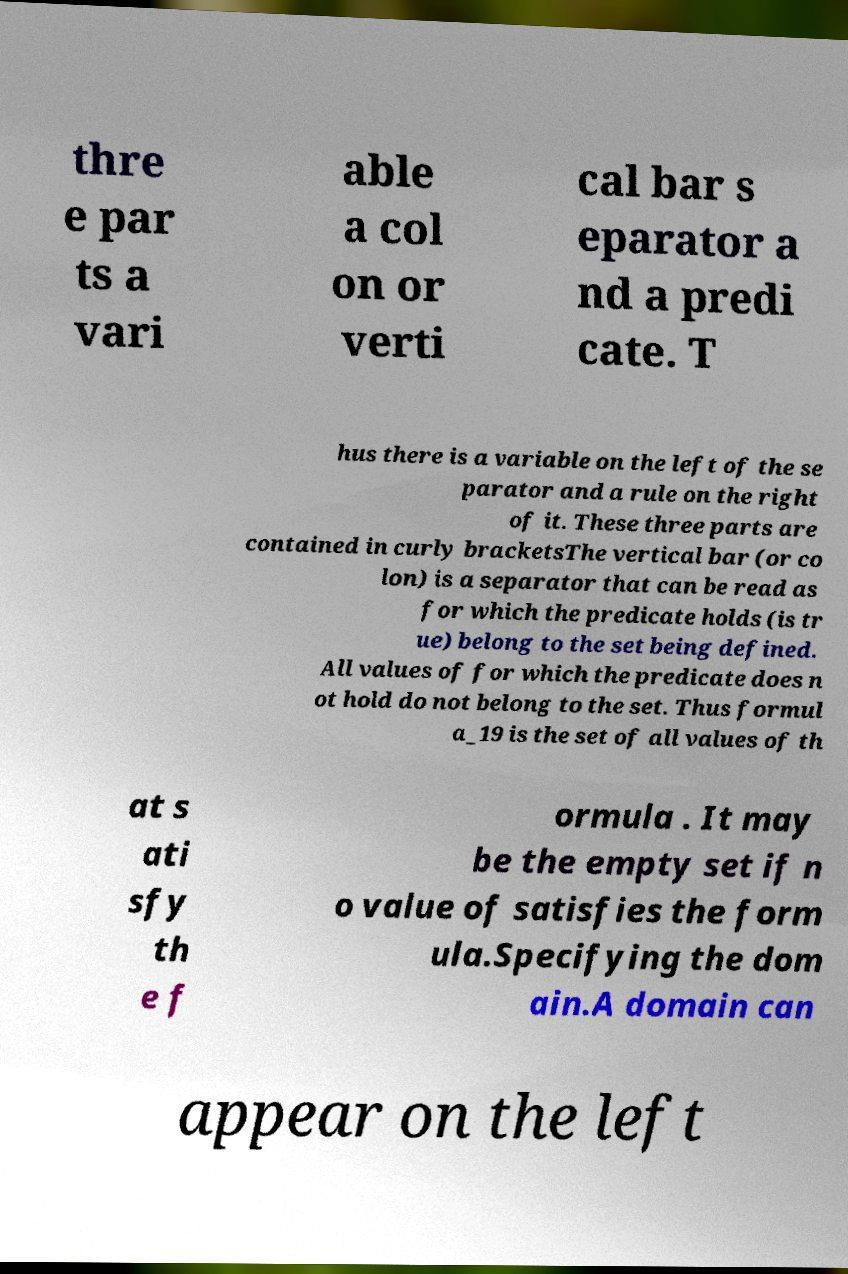I need the written content from this picture converted into text. Can you do that? thre e par ts a vari able a col on or verti cal bar s eparator a nd a predi cate. T hus there is a variable on the left of the se parator and a rule on the right of it. These three parts are contained in curly bracketsThe vertical bar (or co lon) is a separator that can be read as for which the predicate holds (is tr ue) belong to the set being defined. All values of for which the predicate does n ot hold do not belong to the set. Thus formul a_19 is the set of all values of th at s ati sfy th e f ormula . It may be the empty set if n o value of satisfies the form ula.Specifying the dom ain.A domain can appear on the left 